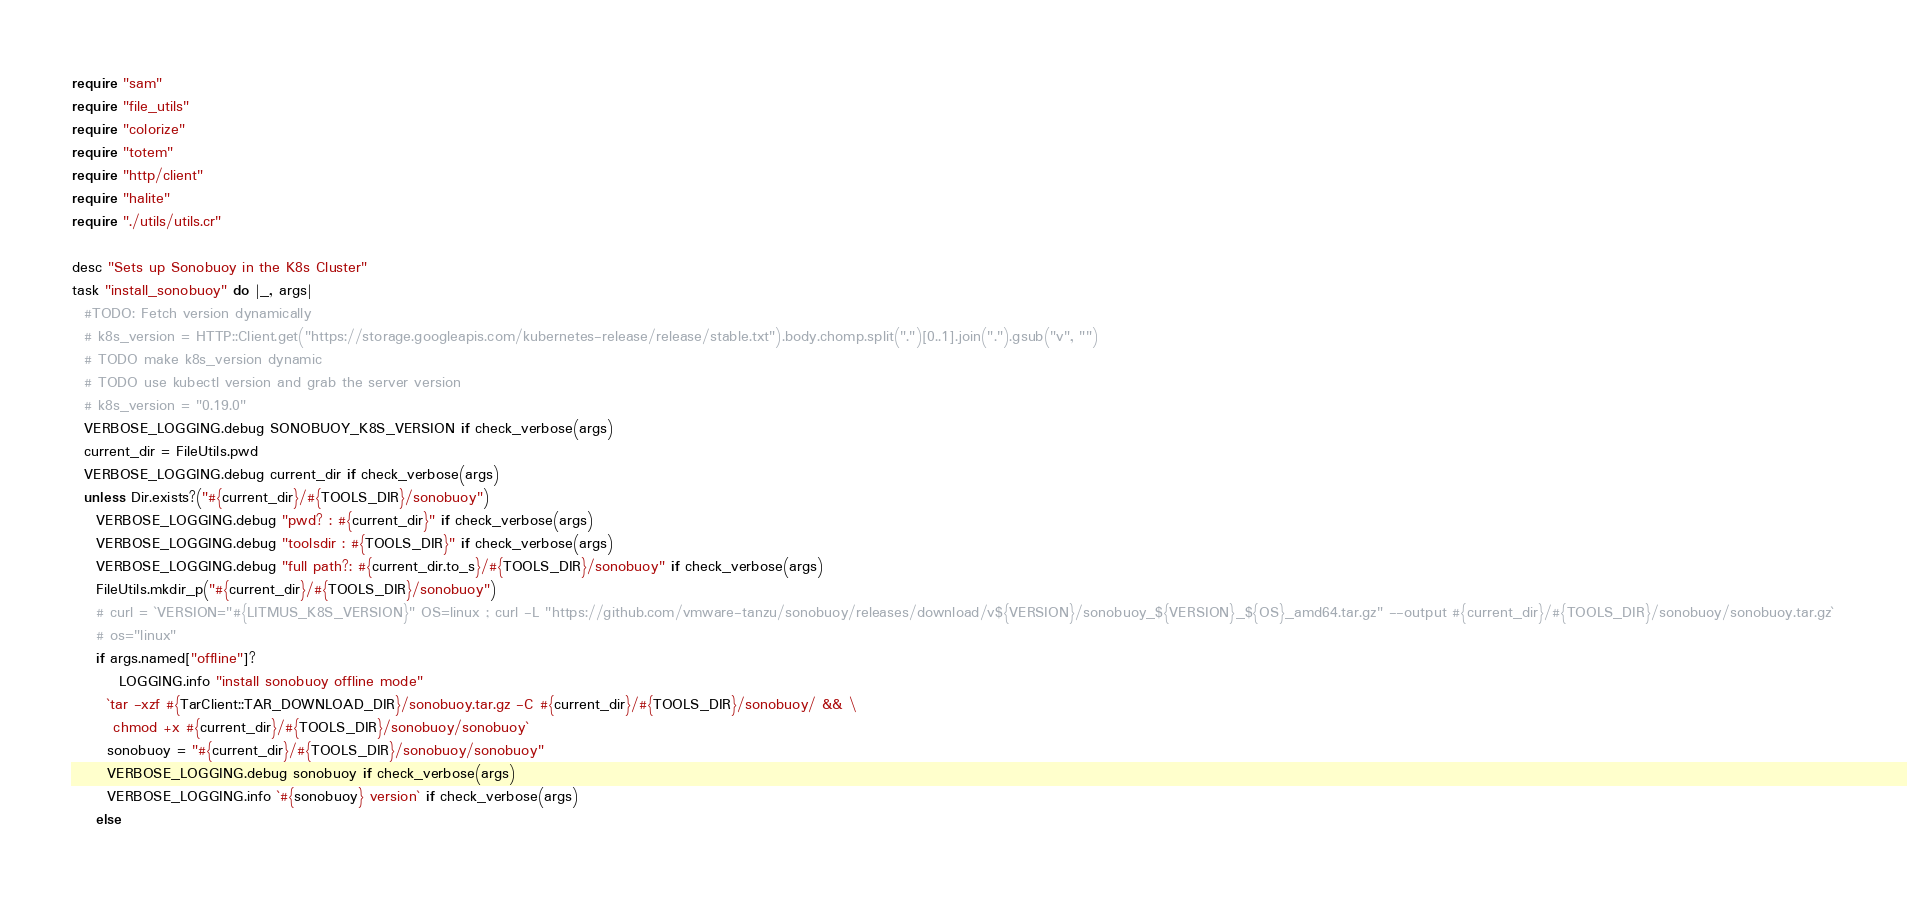<code> <loc_0><loc_0><loc_500><loc_500><_Crystal_>require "sam"
require "file_utils"
require "colorize"
require "totem"
require "http/client"
require "halite" 
require "./utils/utils.cr"

desc "Sets up Sonobuoy in the K8s Cluster"
task "install_sonobuoy" do |_, args|
  #TODO: Fetch version dynamically
  # k8s_version = HTTP::Client.get("https://storage.googleapis.com/kubernetes-release/release/stable.txt").body.chomp.split(".")[0..1].join(".").gsub("v", "") 
  # TODO make k8s_version dynamic
  # TODO use kubectl version and grab the server version
  # k8s_version = "0.19.0"
  VERBOSE_LOGGING.debug SONOBUOY_K8S_VERSION if check_verbose(args)
  current_dir = FileUtils.pwd 
  VERBOSE_LOGGING.debug current_dir if check_verbose(args)
  unless Dir.exists?("#{current_dir}/#{TOOLS_DIR}/sonobuoy")
    VERBOSE_LOGGING.debug "pwd? : #{current_dir}" if check_verbose(args)
    VERBOSE_LOGGING.debug "toolsdir : #{TOOLS_DIR}" if check_verbose(args)
    VERBOSE_LOGGING.debug "full path?: #{current_dir.to_s}/#{TOOLS_DIR}/sonobuoy" if check_verbose(args)
    FileUtils.mkdir_p("#{current_dir}/#{TOOLS_DIR}/sonobuoy") 
    # curl = `VERSION="#{LITMUS_K8S_VERSION}" OS=linux ; curl -L "https://github.com/vmware-tanzu/sonobuoy/releases/download/v${VERSION}/sonobuoy_${VERSION}_${OS}_amd64.tar.gz" --output #{current_dir}/#{TOOLS_DIR}/sonobuoy/sonobuoy.tar.gz`
    # os="linux"
    if args.named["offline"]?
        LOGGING.info "install sonobuoy offline mode"
      `tar -xzf #{TarClient::TAR_DOWNLOAD_DIR}/sonobuoy.tar.gz -C #{current_dir}/#{TOOLS_DIR}/sonobuoy/ && \
       chmod +x #{current_dir}/#{TOOLS_DIR}/sonobuoy/sonobuoy`
      sonobuoy = "#{current_dir}/#{TOOLS_DIR}/sonobuoy/sonobuoy"
      VERBOSE_LOGGING.debug sonobuoy if check_verbose(args)
      VERBOSE_LOGGING.info `#{sonobuoy} version` if check_verbose(args)
    else</code> 